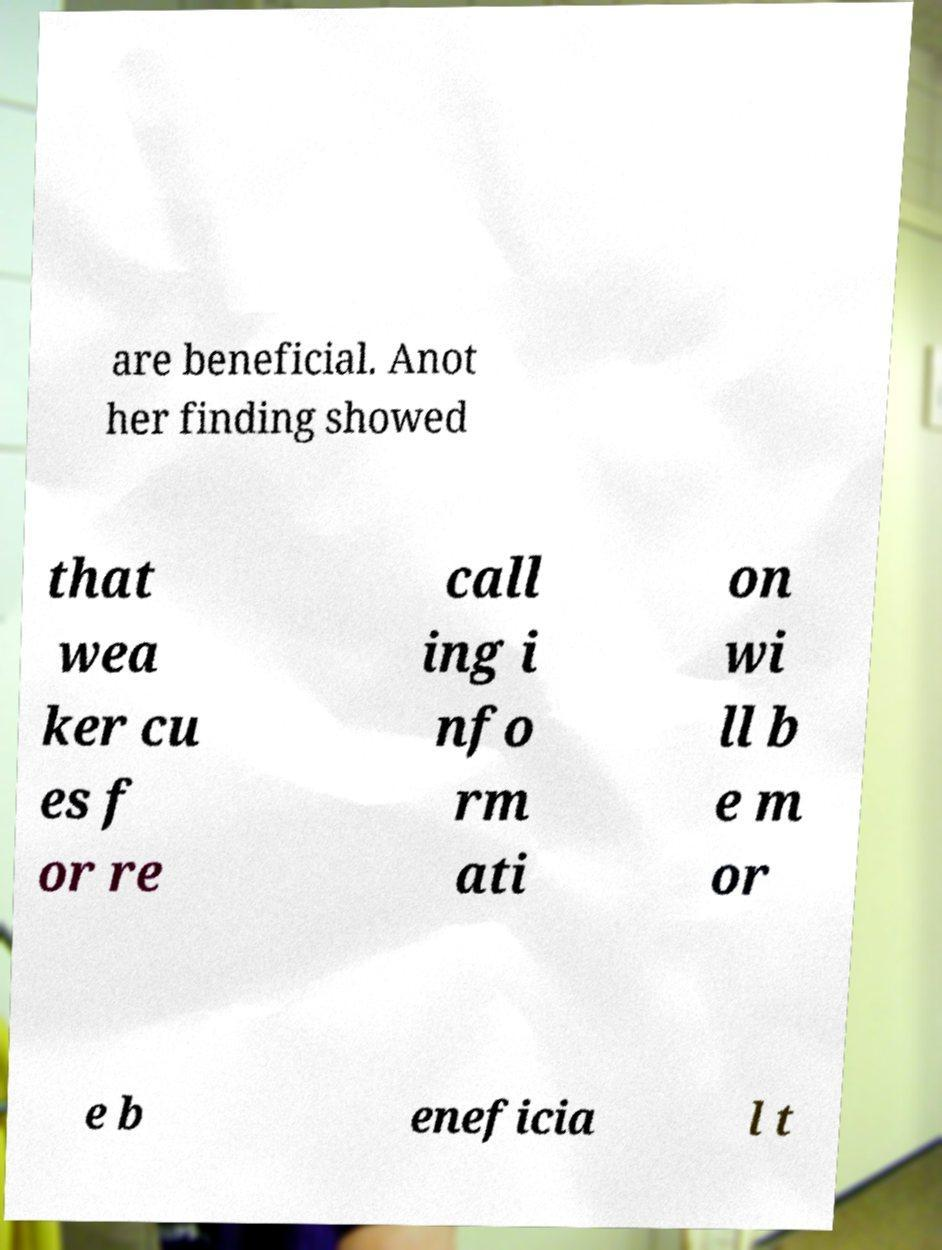Can you accurately transcribe the text from the provided image for me? are beneficial. Anot her finding showed that wea ker cu es f or re call ing i nfo rm ati on wi ll b e m or e b eneficia l t 